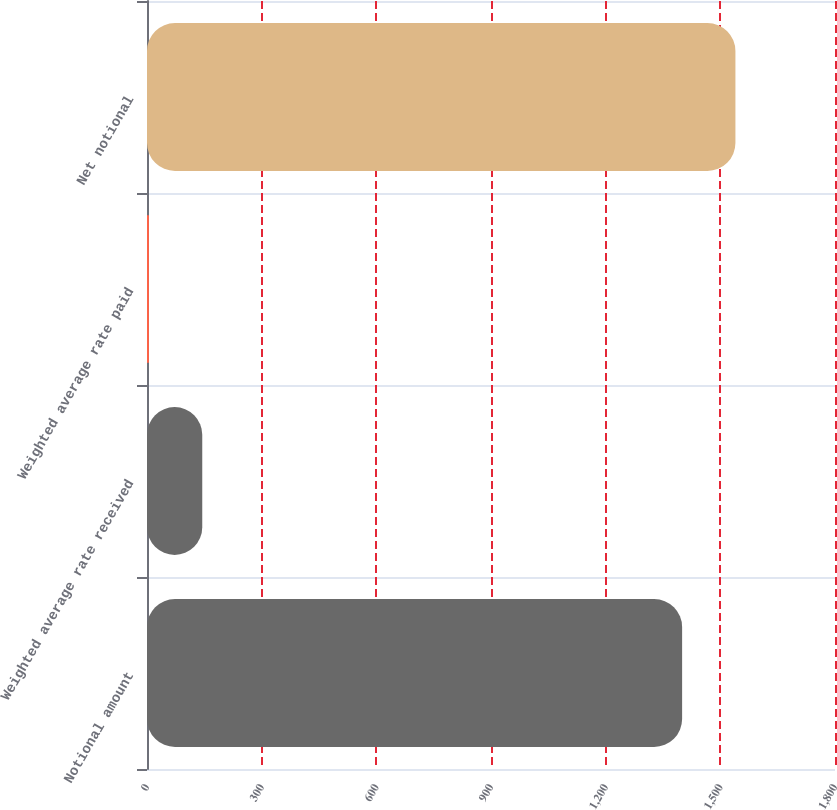Convert chart to OTSL. <chart><loc_0><loc_0><loc_500><loc_500><bar_chart><fcel>Notional amount<fcel>Weighted average rate received<fcel>Weighted average rate paid<fcel>Net notional<nl><fcel>1400<fcel>144.55<fcel>5.05<fcel>1539.49<nl></chart> 